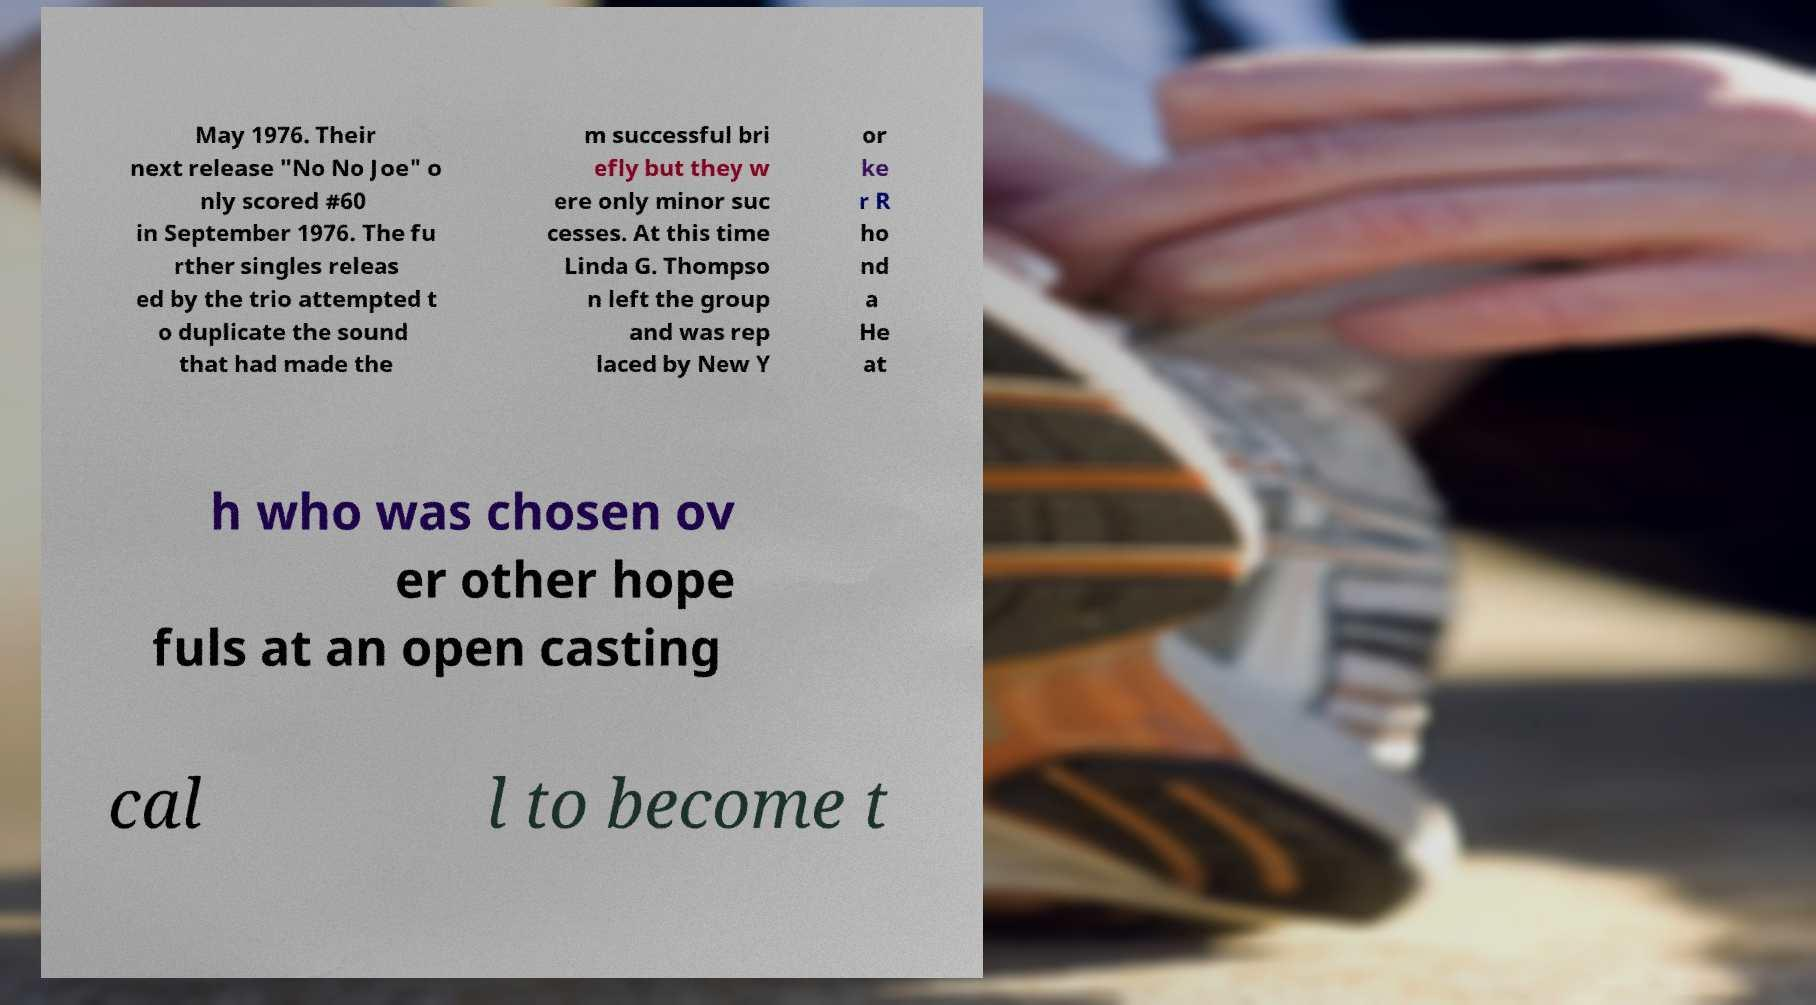Please identify and transcribe the text found in this image. May 1976. Their next release "No No Joe" o nly scored #60 in September 1976. The fu rther singles releas ed by the trio attempted t o duplicate the sound that had made the m successful bri efly but they w ere only minor suc cesses. At this time Linda G. Thompso n left the group and was rep laced by New Y or ke r R ho nd a He at h who was chosen ov er other hope fuls at an open casting cal l to become t 